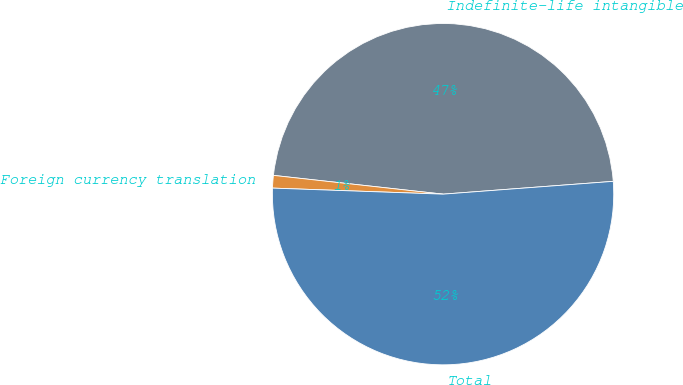Convert chart to OTSL. <chart><loc_0><loc_0><loc_500><loc_500><pie_chart><fcel>Indefinite-life intangible<fcel>Foreign currency translation<fcel>Total<nl><fcel>47.05%<fcel>1.19%<fcel>51.76%<nl></chart> 